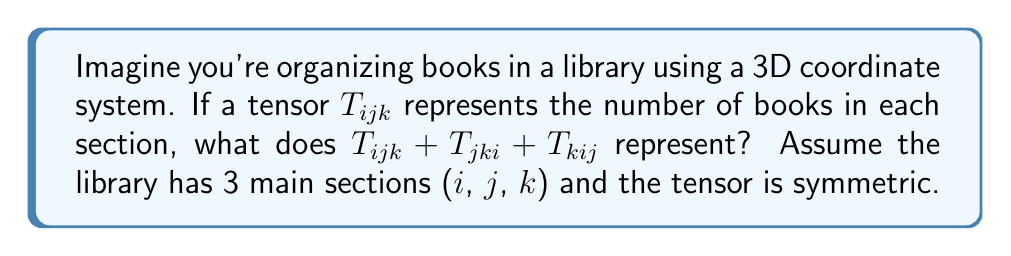Could you help me with this problem? Let's break this down step-by-step:

1) First, we need to understand what $T_{ijk}$ represents:
   - $i$, $j$, and $k$ are indices representing the three main sections of the library.
   - $T_{ijk}$ gives the number of books in a specific subsection.

2) The tensor is symmetric, which means:
   $T_{ijk} = T_{jki} = T_{kij}$ for all permutations of i, j, and k.

3) Now, let's look at the expression $T_{ijk} + T_{jki} + T_{kij}$:
   - Due to the symmetry, each term is equal to the others.
   - So, this sum is equivalent to $3T_{ijk}$.

4) What does $3T_{ijk}$ represent?
   - It's three times the number of books in each subsection.

5) In the context of library organization:
   - This sum represents the total number of books in a subsection, counted three times.

6) To get the actual number of books, we would need to divide by 3:
   $\frac{1}{3}(T_{ijk} + T_{jki} + T_{kij}) = T_{ijk}$

Therefore, $T_{ijk} + T_{jki} + T_{kij}$ represents triple the actual number of books in each subsection of the library.
Answer: Triple the number of books in each subsection 